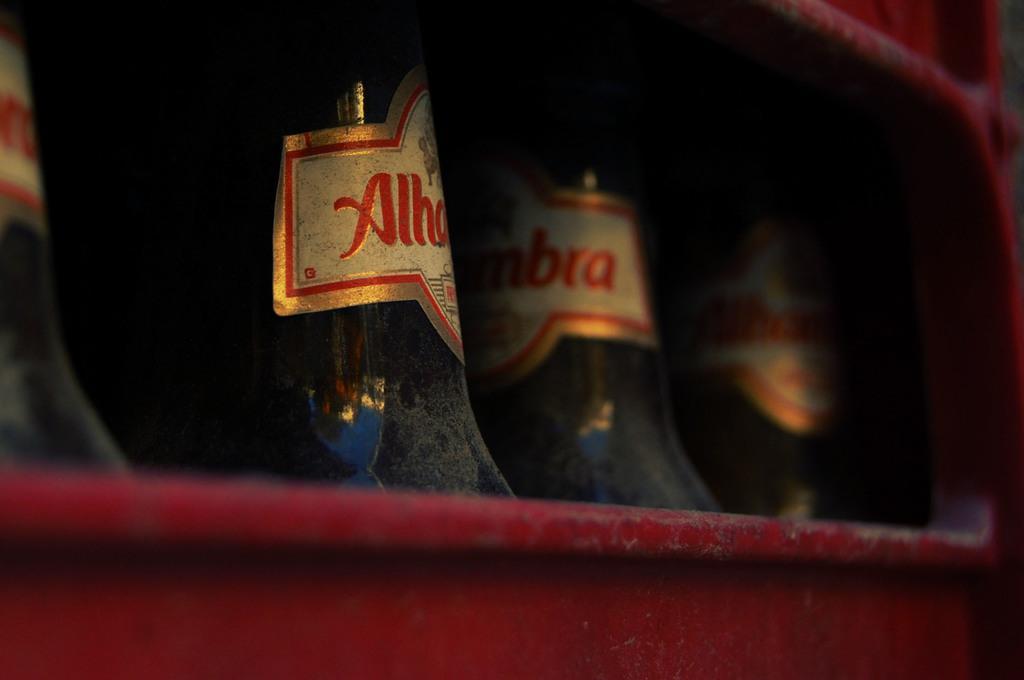Can you describe this image briefly? In this image I can see the red colored object and in it I can see few glass bottles which are black in color. I can see cream, red and gold colored stickers attached to the bottles. 